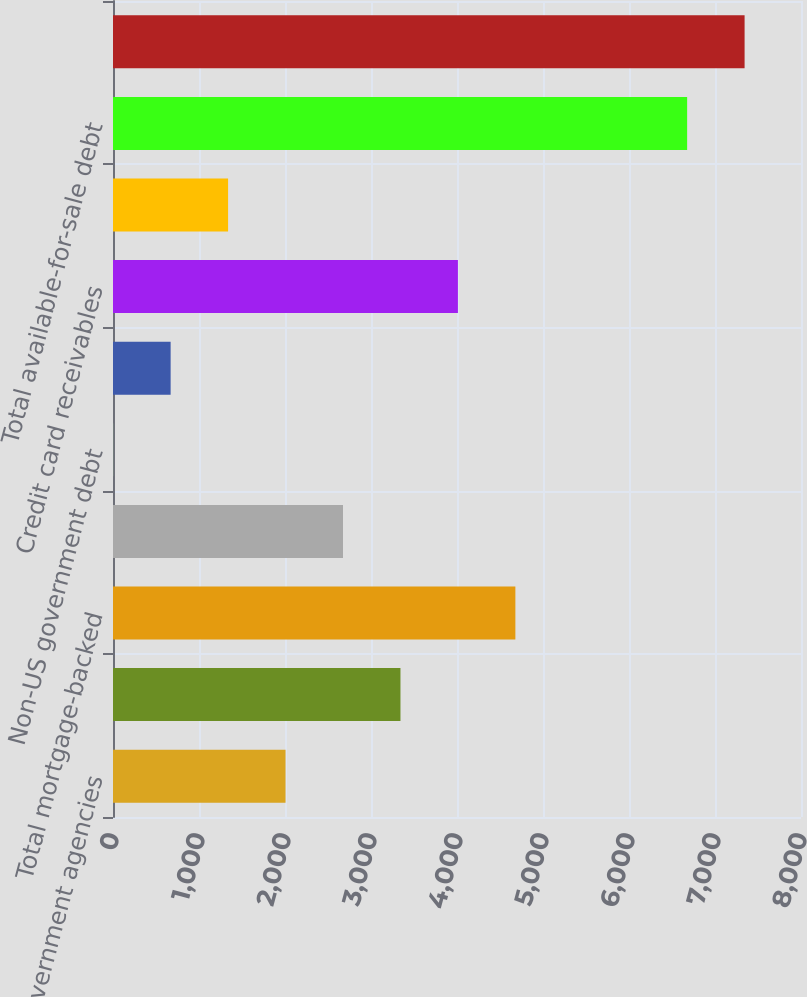Convert chart to OTSL. <chart><loc_0><loc_0><loc_500><loc_500><bar_chart><fcel>US government agencies<fcel>Prime and Alt-A<fcel>Total mortgage-backed<fcel>Obligations of US states and<fcel>Non-US government debt<fcel>Corporate debt securities<fcel>Credit card receivables<fcel>Other<fcel>Total available-for-sale debt<fcel>Total securities with gross<nl><fcel>2006.3<fcel>3342.5<fcel>4678.7<fcel>2674.4<fcel>2<fcel>670.1<fcel>4010.6<fcel>1338.2<fcel>6676<fcel>7344.1<nl></chart> 